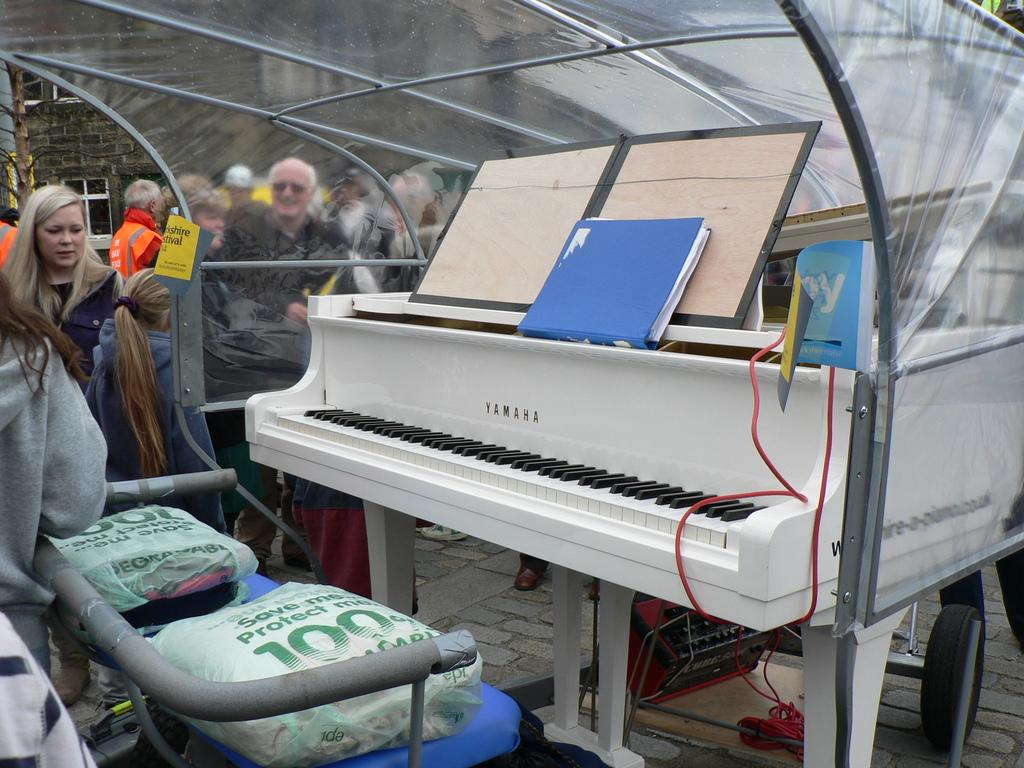What musical instrument is present in the image? There is a piano in the image. What is located in front of the piano? There are two seats in front of the piano. What object is placed on the piano? There is a file on the piano. Can you describe the people visible in the background of the image? Unfortunately, the facts provided do not give any details about the people in the background. How many centimeters long is the coil on the piano? There is no coil present on the piano in the image. 